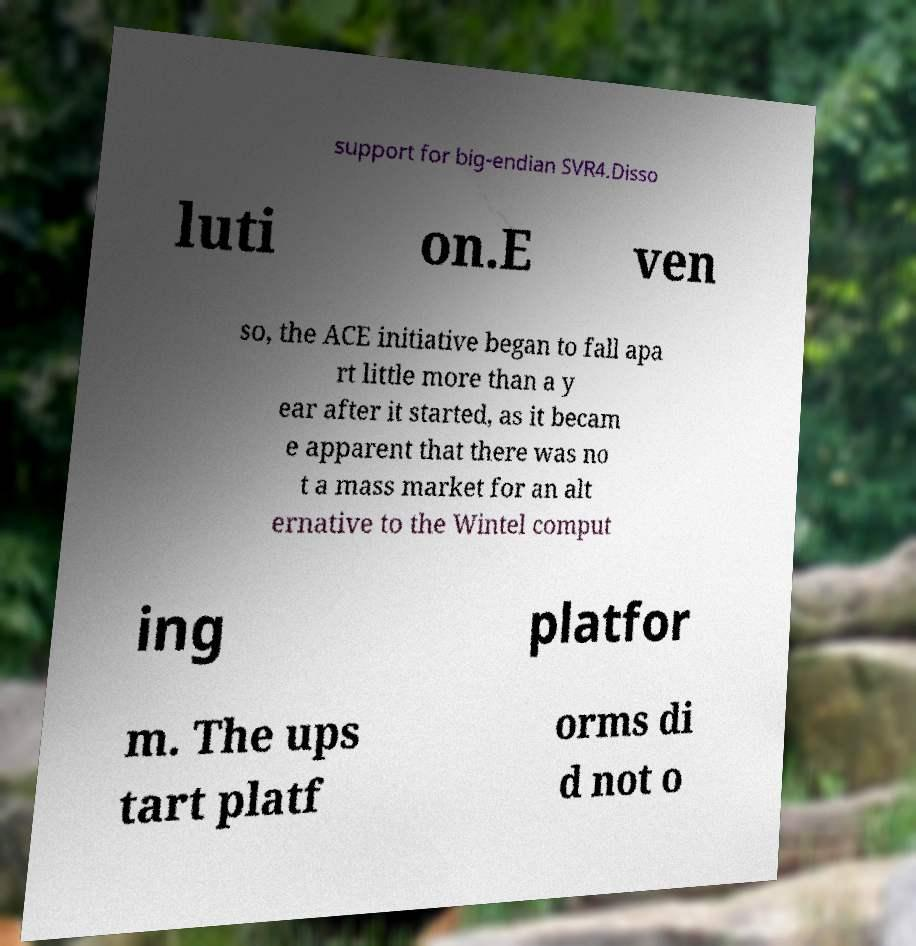Please read and relay the text visible in this image. What does it say? support for big-endian SVR4.Disso luti on.E ven so, the ACE initiative began to fall apa rt little more than a y ear after it started, as it becam e apparent that there was no t a mass market for an alt ernative to the Wintel comput ing platfor m. The ups tart platf orms di d not o 